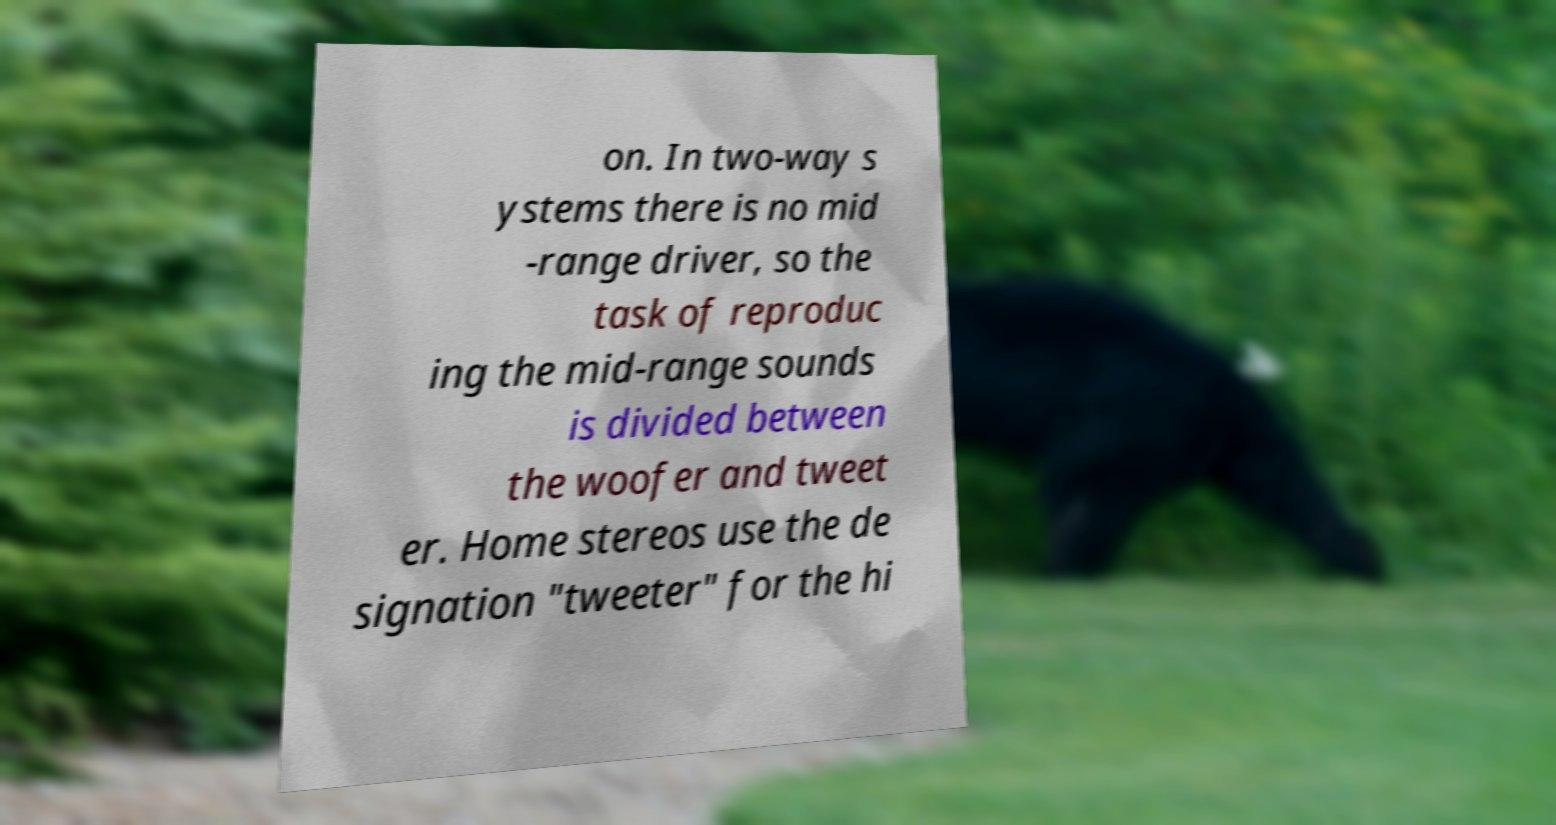What messages or text are displayed in this image? I need them in a readable, typed format. on. In two-way s ystems there is no mid -range driver, so the task of reproduc ing the mid-range sounds is divided between the woofer and tweet er. Home stereos use the de signation "tweeter" for the hi 